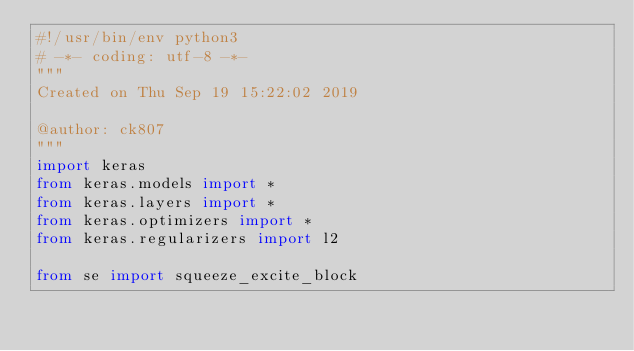<code> <loc_0><loc_0><loc_500><loc_500><_Python_>#!/usr/bin/env python3
# -*- coding: utf-8 -*-
"""
Created on Thu Sep 19 15:22:02 2019

@author: ck807
"""
import keras
from keras.models import *
from keras.layers import *
from keras.optimizers import *
from keras.regularizers import l2

from se import squeeze_excite_block</code> 